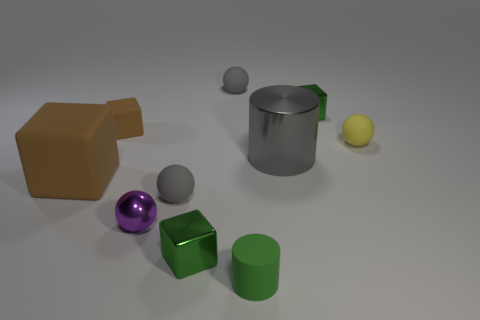What number of green things are cubes or small shiny cubes?
Your answer should be compact. 2. There is a tiny shiny ball; are there any gray rubber spheres to the left of it?
Your answer should be compact. No. Is the shape of the small gray thing that is behind the large brown matte object the same as the small purple object left of the big gray object?
Offer a very short reply. Yes. What is the material of the tiny brown thing that is the same shape as the large brown rubber object?
Give a very brief answer. Rubber. What number of balls are small things or big rubber things?
Offer a terse response. 4. What number of green objects have the same material as the big gray cylinder?
Provide a succinct answer. 2. Is the material of the small green block that is in front of the big cube the same as the large thing on the right side of the tiny rubber cylinder?
Give a very brief answer. Yes. What number of metal blocks are behind the green metallic cube that is in front of the gray matte object that is in front of the large gray object?
Offer a very short reply. 1. There is a shiny block behind the big brown rubber thing; is its color the same as the matte block in front of the large gray thing?
Offer a terse response. No. Is there anything else that has the same color as the metal ball?
Provide a succinct answer. No. 